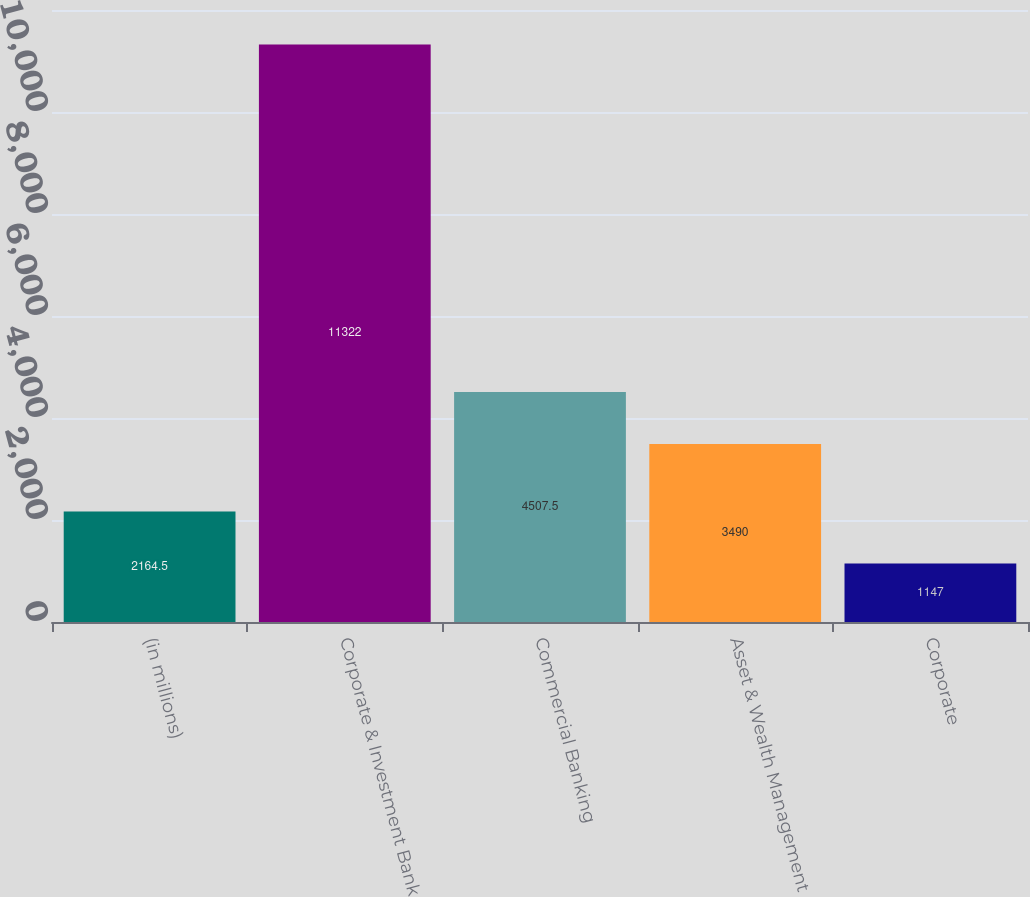<chart> <loc_0><loc_0><loc_500><loc_500><bar_chart><fcel>(in millions)<fcel>Corporate & Investment Bank<fcel>Commercial Banking<fcel>Asset & Wealth Management<fcel>Corporate<nl><fcel>2164.5<fcel>11322<fcel>4507.5<fcel>3490<fcel>1147<nl></chart> 